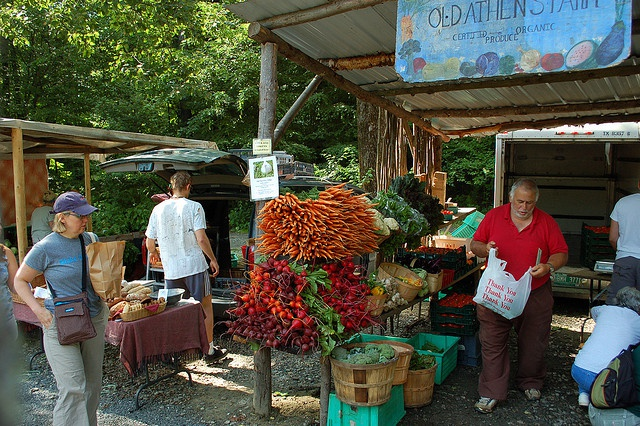Describe the objects in this image and their specific colors. I can see truck in darkgreen, black, white, darkgray, and gray tones, people in darkgreen, black, brown, maroon, and lightblue tones, people in darkgreen, gray, darkgray, and black tones, dining table in darkgreen, maroon, black, and gray tones, and carrot in darkgreen, maroon, brown, and black tones in this image. 